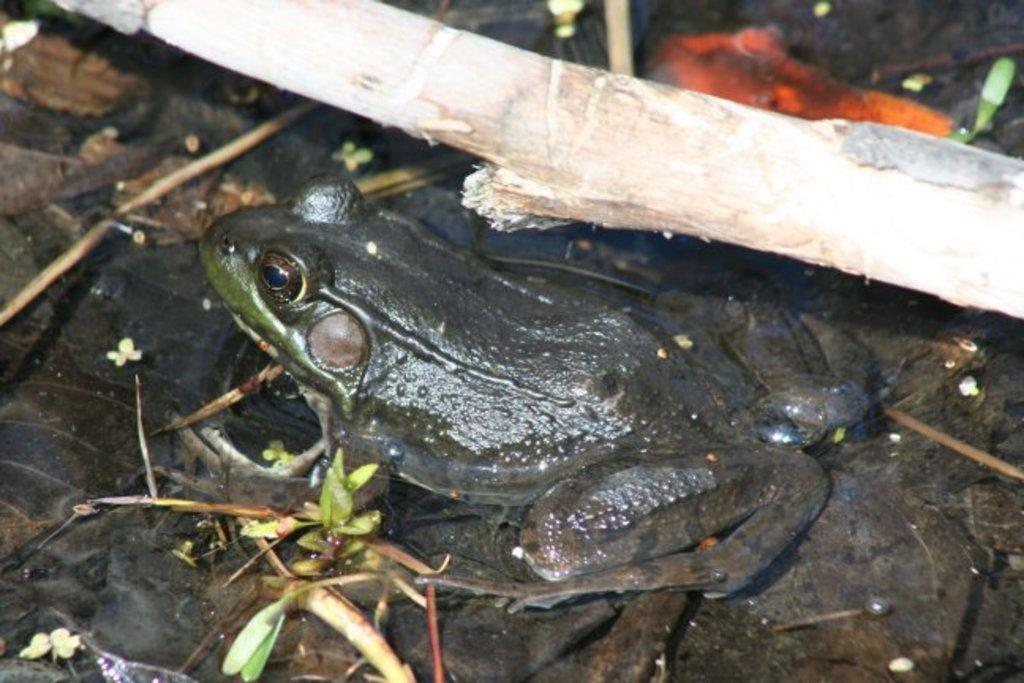What animal is present in the image? There is a frog in the image. What is the frog sitting on? The frog is on leaves. What can be seen above the frog? There is steam above the frog. What type of gold material is draped over the frog in the image? There is no gold material present in the image; the frog is sitting on leaves with steam above it. 